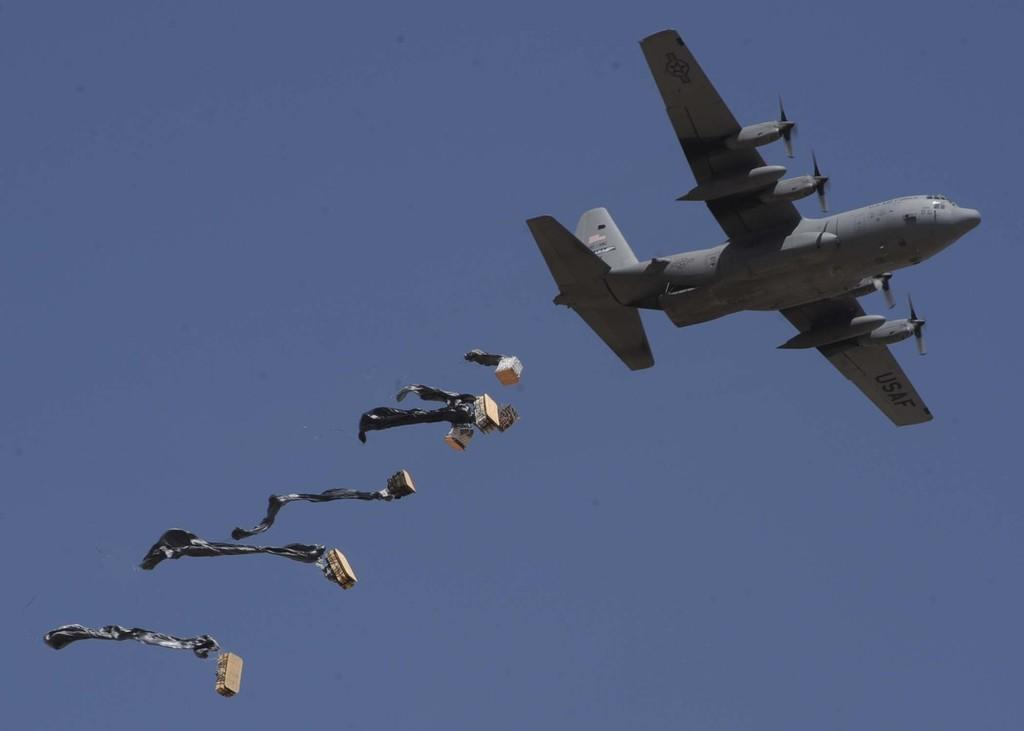What is the main subject of the picture? The main subject of the picture is an airplane. What else is flying in the picture besides the airplane? There are objects flying in the picture. What can be seen in the background of the picture? The sky is visible in the background of the picture. Can you tell me how many guitars are being played by the baseball players in the image? There are no baseball players or guitars present in the image; it features an airplane and objects flying in the sky. 